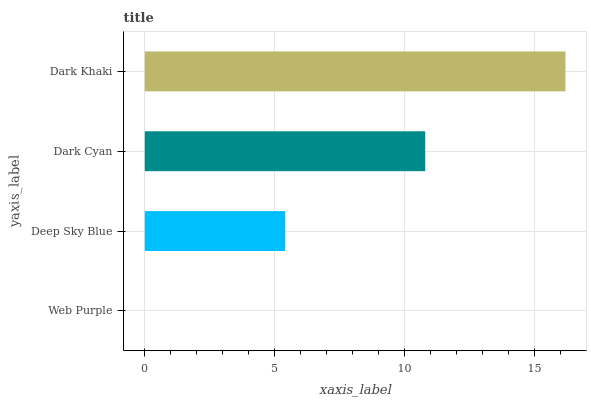Is Web Purple the minimum?
Answer yes or no. Yes. Is Dark Khaki the maximum?
Answer yes or no. Yes. Is Deep Sky Blue the minimum?
Answer yes or no. No. Is Deep Sky Blue the maximum?
Answer yes or no. No. Is Deep Sky Blue greater than Web Purple?
Answer yes or no. Yes. Is Web Purple less than Deep Sky Blue?
Answer yes or no. Yes. Is Web Purple greater than Deep Sky Blue?
Answer yes or no. No. Is Deep Sky Blue less than Web Purple?
Answer yes or no. No. Is Dark Cyan the high median?
Answer yes or no. Yes. Is Deep Sky Blue the low median?
Answer yes or no. Yes. Is Deep Sky Blue the high median?
Answer yes or no. No. Is Web Purple the low median?
Answer yes or no. No. 